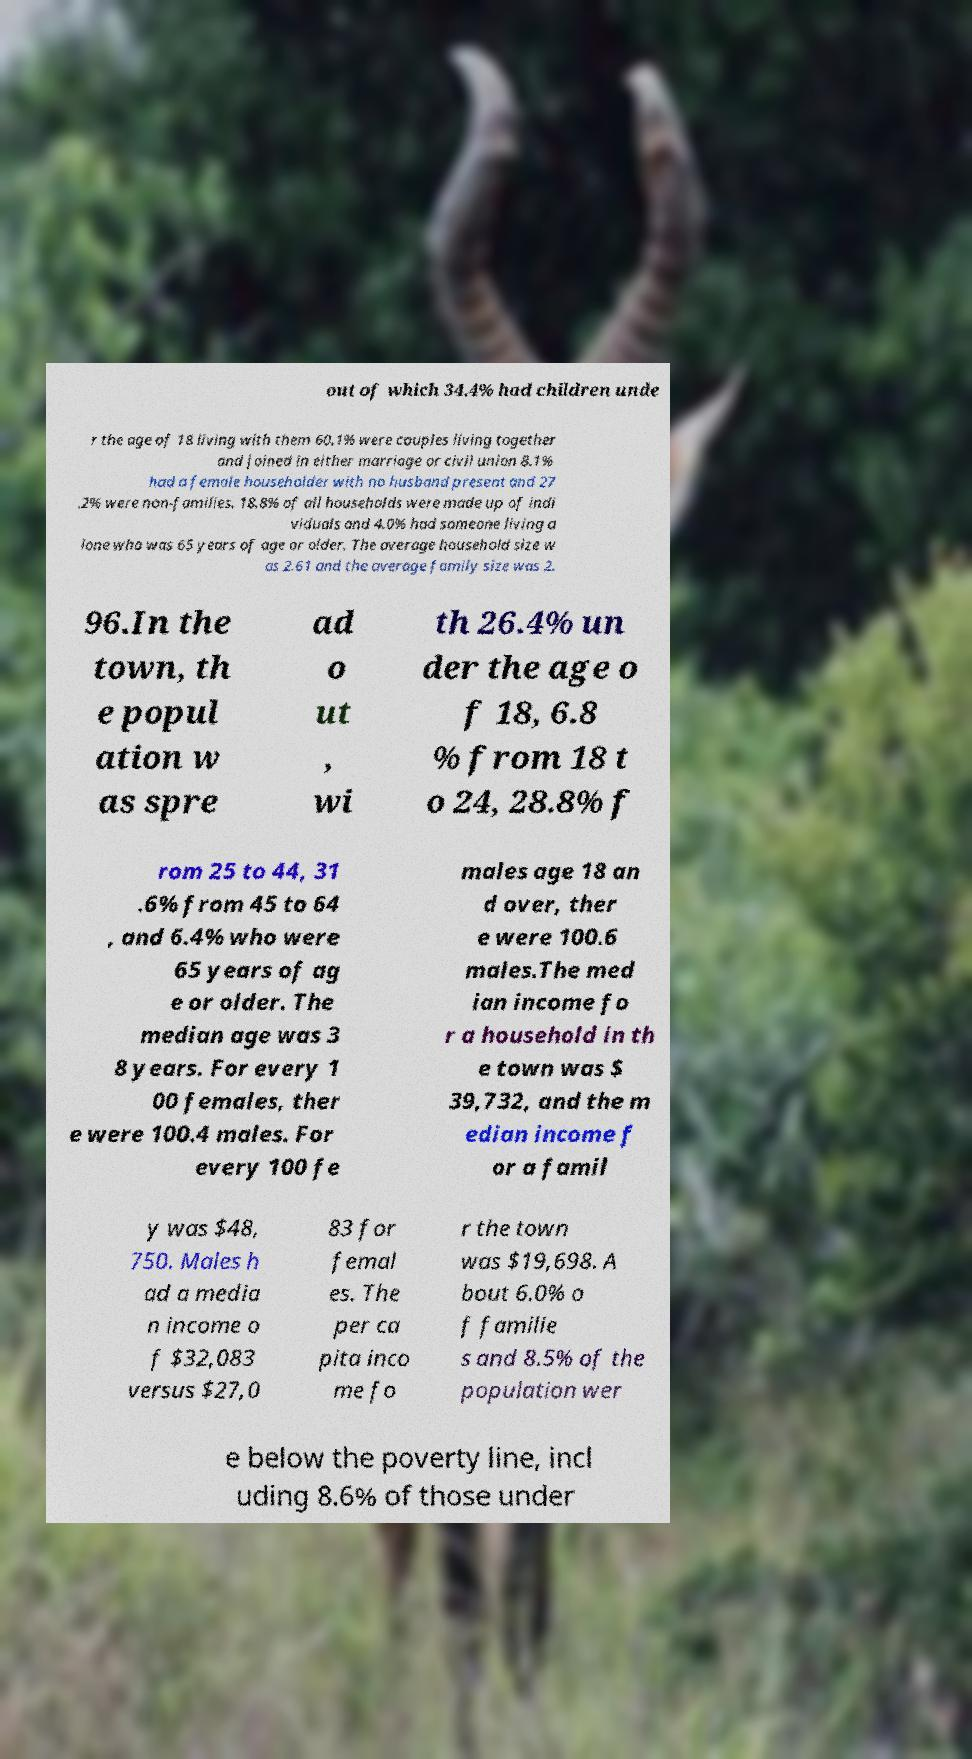What messages or text are displayed in this image? I need them in a readable, typed format. out of which 34.4% had children unde r the age of 18 living with them 60.1% were couples living together and joined in either marriage or civil union 8.1% had a female householder with no husband present and 27 .2% were non-families. 18.8% of all households were made up of indi viduals and 4.0% had someone living a lone who was 65 years of age or older. The average household size w as 2.61 and the average family size was 2. 96.In the town, th e popul ation w as spre ad o ut , wi th 26.4% un der the age o f 18, 6.8 % from 18 t o 24, 28.8% f rom 25 to 44, 31 .6% from 45 to 64 , and 6.4% who were 65 years of ag e or older. The median age was 3 8 years. For every 1 00 females, ther e were 100.4 males. For every 100 fe males age 18 an d over, ther e were 100.6 males.The med ian income fo r a household in th e town was $ 39,732, and the m edian income f or a famil y was $48, 750. Males h ad a media n income o f $32,083 versus $27,0 83 for femal es. The per ca pita inco me fo r the town was $19,698. A bout 6.0% o f familie s and 8.5% of the population wer e below the poverty line, incl uding 8.6% of those under 